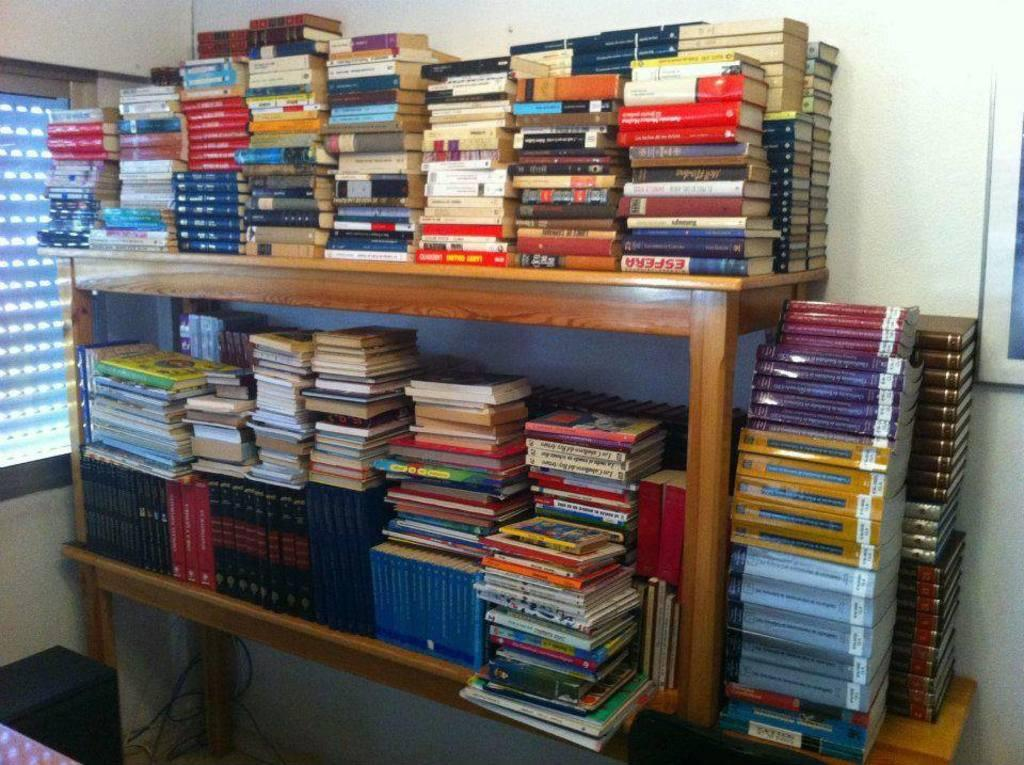How are the books arranged in the image? The books are arranged in an order, one upon the other, in the image. Where are the books located? The books are on shelves in the image. What can be seen in the background of the image? There is a frame attached to the wall in the background of the image. What type of lock is used to secure the roof in the image? There is no mention of a roof or a lock in the image; it features books arranged on shelves with a frame in the background. 